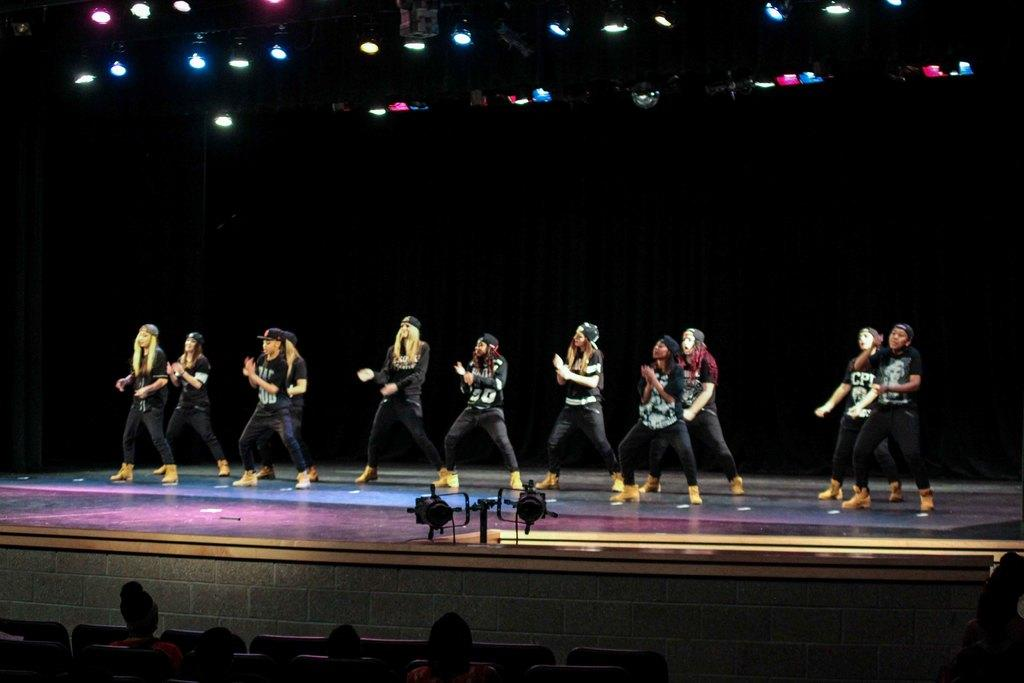What are the people in the image doing while sitting on chairs? The facts provided do not specify what the people are doing while sitting on chairs. What is happening on the stage in the image? There is a group of people dancing on a stage in the image. What type of lighting is present in the image? Focus lights are present in the image. What other objects can be seen in the image besides the people and the stage? There are other objects visible in the image, but their specific nature is not mentioned in the provided facts. What month is it in the image? The provided facts do not mention any information about the month or time of year in the image. Can you provide an example of another object visible in the image? The provided facts do not specify any other objects visible in the image, so it is impossible to provide an example. 